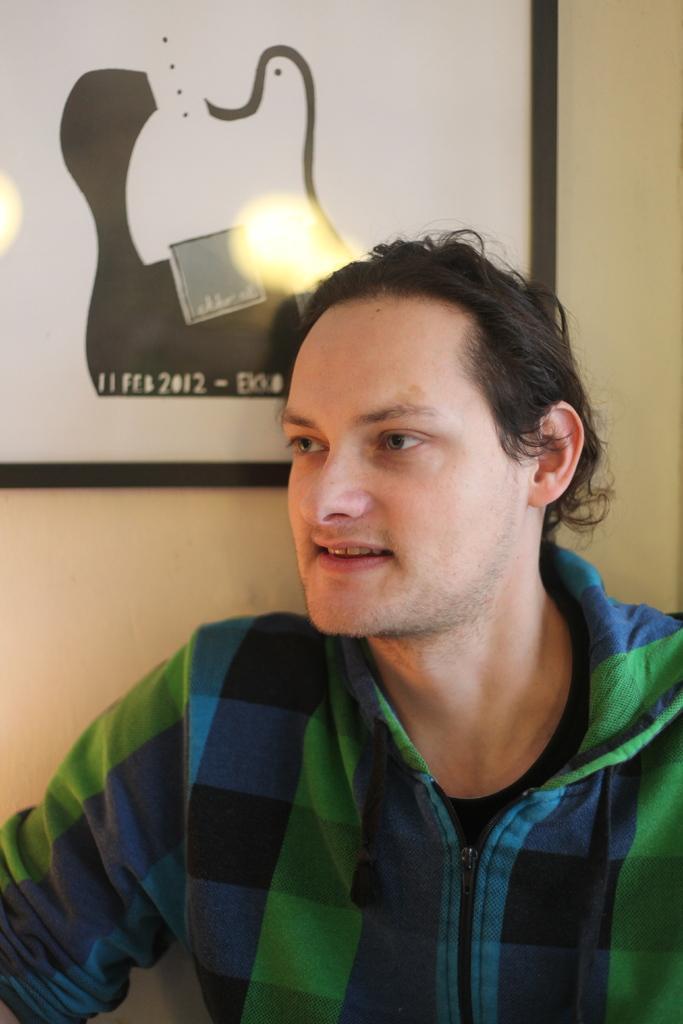Can you describe this image briefly? In this picture I can see a person, behind there is a frame to the wall. 